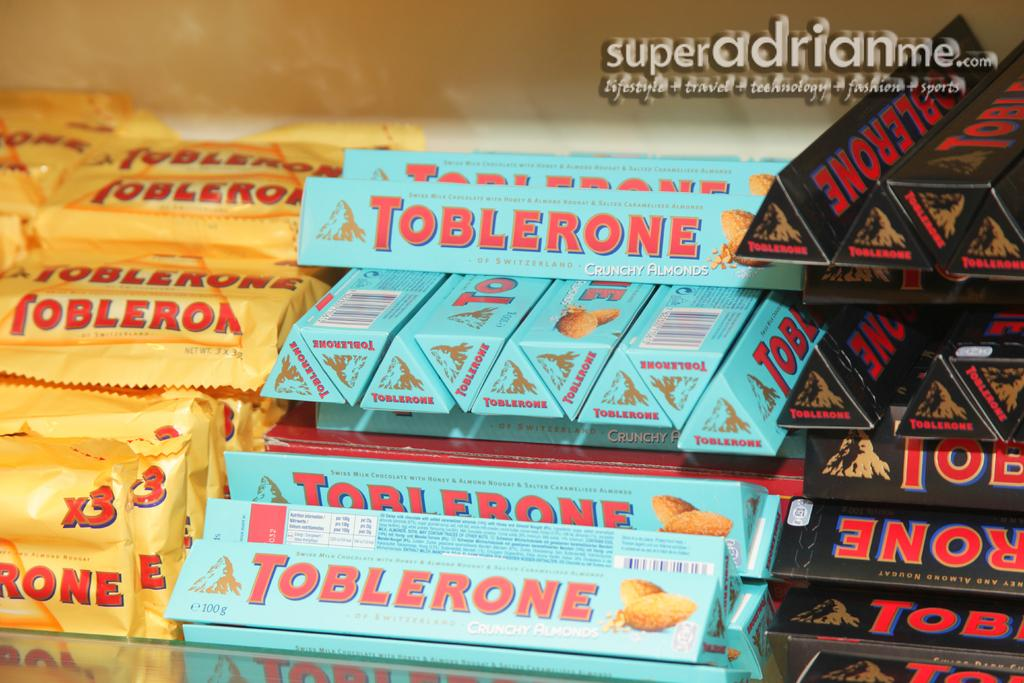<image>
Present a compact description of the photo's key features. Three different flavors of Toblerone chocolate, regular in yellow packaging, crunchy almond in blue packaging, and an unknown flavor in black packaging 